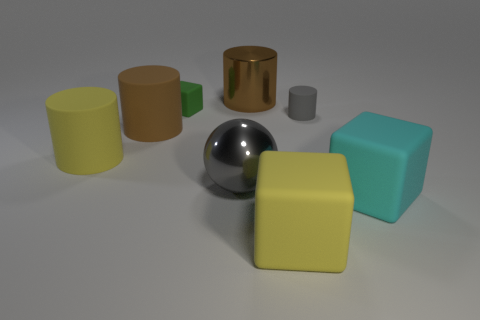How many big gray metal balls are there?
Provide a succinct answer. 1. Is the number of large shiny cylinders that are in front of the cyan object less than the number of purple rubber spheres?
Give a very brief answer. No. Is the big thing right of the small cylinder made of the same material as the yellow cube?
Offer a terse response. Yes. The big object behind the small rubber thing right of the large yellow object that is on the right side of the large yellow matte cylinder is what shape?
Keep it short and to the point. Cylinder. Is there a cyan cube that has the same size as the yellow rubber cylinder?
Ensure brevity in your answer.  Yes. What is the size of the gray metal ball?
Give a very brief answer. Large. What number of yellow matte cubes have the same size as the green matte cube?
Provide a succinct answer. 0. Are there fewer small things that are to the left of the metallic cylinder than large gray metal things that are right of the large cyan matte thing?
Make the answer very short. No. How big is the yellow matte thing left of the yellow thing in front of the cyan rubber thing on the right side of the brown matte cylinder?
Ensure brevity in your answer.  Large. There is a thing that is both in front of the yellow rubber cylinder and behind the big cyan thing; what is its size?
Provide a succinct answer. Large. 